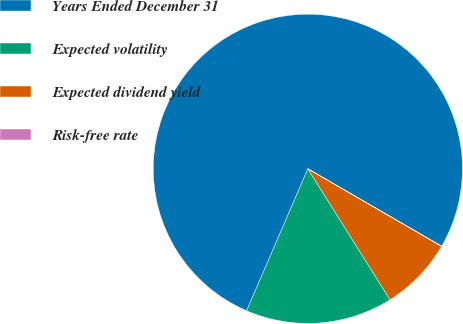<chart> <loc_0><loc_0><loc_500><loc_500><pie_chart><fcel>Years Ended December 31<fcel>Expected volatility<fcel>Expected dividend yield<fcel>Risk-free rate<nl><fcel>76.86%<fcel>15.4%<fcel>7.71%<fcel>0.03%<nl></chart> 